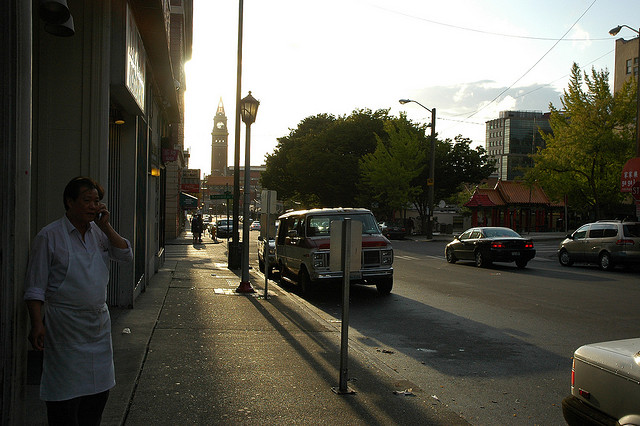<image>What is behind the food truck? It is unclear what is behind the food truck. It might be a car, a van, a person, a clock tower, or a building. What is behind the food truck? I am not sure what is behind the food truck. It can be seen car, van, person, clock tower or building. 